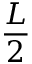<formula> <loc_0><loc_0><loc_500><loc_500>\frac { L } { 2 }</formula> 